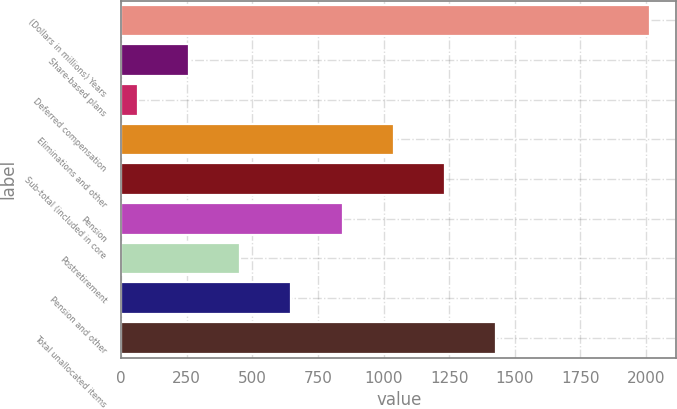Convert chart. <chart><loc_0><loc_0><loc_500><loc_500><bar_chart><fcel>(Dollars in millions) Years<fcel>Share-based plans<fcel>Deferred compensation<fcel>Eliminations and other<fcel>Sub-total (included in core<fcel>Pension<fcel>Postretirement<fcel>Pension and other<fcel>Total unallocated items<nl><fcel>2015<fcel>258.2<fcel>63<fcel>1039<fcel>1234.2<fcel>843.8<fcel>453.4<fcel>648.6<fcel>1429.4<nl></chart> 